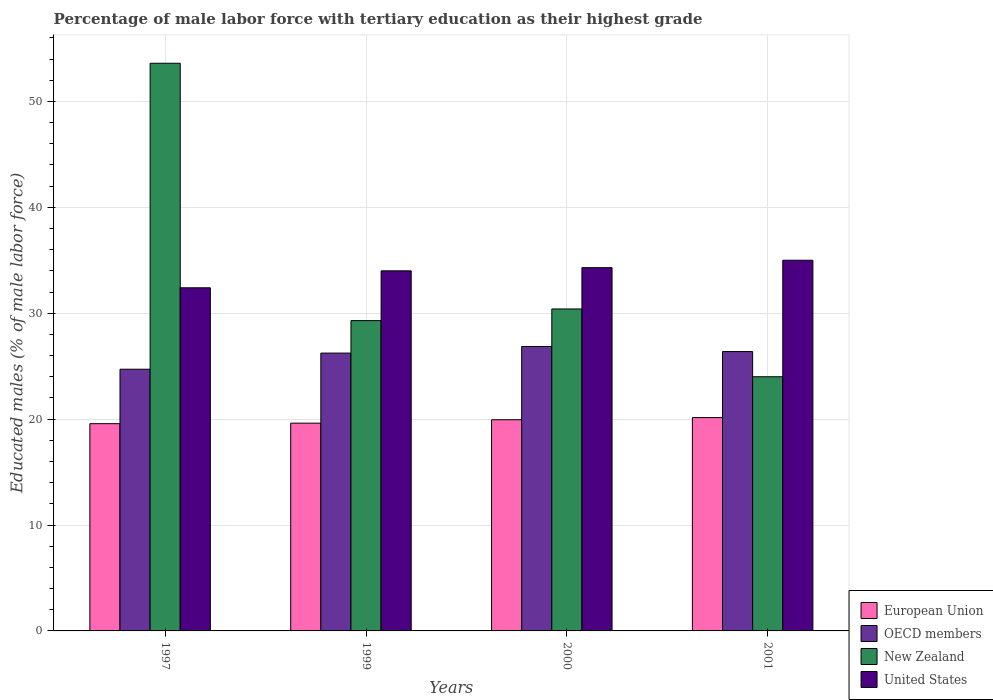How many groups of bars are there?
Offer a very short reply. 4. What is the label of the 1st group of bars from the left?
Your answer should be very brief. 1997. In how many cases, is the number of bars for a given year not equal to the number of legend labels?
Offer a very short reply. 0. What is the percentage of male labor force with tertiary education in European Union in 1999?
Your response must be concise. 19.62. Across all years, what is the maximum percentage of male labor force with tertiary education in OECD members?
Provide a succinct answer. 26.85. Across all years, what is the minimum percentage of male labor force with tertiary education in OECD members?
Give a very brief answer. 24.71. In which year was the percentage of male labor force with tertiary education in OECD members maximum?
Make the answer very short. 2000. In which year was the percentage of male labor force with tertiary education in United States minimum?
Give a very brief answer. 1997. What is the total percentage of male labor force with tertiary education in New Zealand in the graph?
Offer a very short reply. 137.3. What is the difference between the percentage of male labor force with tertiary education in European Union in 1999 and that in 2001?
Your response must be concise. -0.52. What is the difference between the percentage of male labor force with tertiary education in European Union in 2000 and the percentage of male labor force with tertiary education in OECD members in 1997?
Make the answer very short. -4.77. What is the average percentage of male labor force with tertiary education in New Zealand per year?
Offer a very short reply. 34.32. In the year 2000, what is the difference between the percentage of male labor force with tertiary education in New Zealand and percentage of male labor force with tertiary education in OECD members?
Give a very brief answer. 3.55. In how many years, is the percentage of male labor force with tertiary education in United States greater than 40 %?
Give a very brief answer. 0. What is the ratio of the percentage of male labor force with tertiary education in United States in 1997 to that in 1999?
Your answer should be compact. 0.95. Is the percentage of male labor force with tertiary education in OECD members in 1997 less than that in 1999?
Provide a succinct answer. Yes. What is the difference between the highest and the second highest percentage of male labor force with tertiary education in European Union?
Keep it short and to the point. 0.2. What is the difference between the highest and the lowest percentage of male labor force with tertiary education in New Zealand?
Your answer should be very brief. 29.6. In how many years, is the percentage of male labor force with tertiary education in New Zealand greater than the average percentage of male labor force with tertiary education in New Zealand taken over all years?
Provide a short and direct response. 1. Is it the case that in every year, the sum of the percentage of male labor force with tertiary education in European Union and percentage of male labor force with tertiary education in United States is greater than the sum of percentage of male labor force with tertiary education in New Zealand and percentage of male labor force with tertiary education in OECD members?
Offer a very short reply. Yes. How many years are there in the graph?
Ensure brevity in your answer.  4. What is the difference between two consecutive major ticks on the Y-axis?
Your response must be concise. 10. Does the graph contain any zero values?
Ensure brevity in your answer.  No. Does the graph contain grids?
Make the answer very short. Yes. Where does the legend appear in the graph?
Provide a short and direct response. Bottom right. How are the legend labels stacked?
Your response must be concise. Vertical. What is the title of the graph?
Your answer should be compact. Percentage of male labor force with tertiary education as their highest grade. Does "Belarus" appear as one of the legend labels in the graph?
Ensure brevity in your answer.  No. What is the label or title of the Y-axis?
Offer a terse response. Educated males (% of male labor force). What is the Educated males (% of male labor force) of European Union in 1997?
Give a very brief answer. 19.57. What is the Educated males (% of male labor force) in OECD members in 1997?
Provide a short and direct response. 24.71. What is the Educated males (% of male labor force) of New Zealand in 1997?
Make the answer very short. 53.6. What is the Educated males (% of male labor force) of United States in 1997?
Your answer should be compact. 32.4. What is the Educated males (% of male labor force) in European Union in 1999?
Ensure brevity in your answer.  19.62. What is the Educated males (% of male labor force) of OECD members in 1999?
Keep it short and to the point. 26.23. What is the Educated males (% of male labor force) in New Zealand in 1999?
Your response must be concise. 29.3. What is the Educated males (% of male labor force) in European Union in 2000?
Keep it short and to the point. 19.94. What is the Educated males (% of male labor force) of OECD members in 2000?
Provide a short and direct response. 26.85. What is the Educated males (% of male labor force) of New Zealand in 2000?
Ensure brevity in your answer.  30.4. What is the Educated males (% of male labor force) of United States in 2000?
Offer a terse response. 34.3. What is the Educated males (% of male labor force) in European Union in 2001?
Your response must be concise. 20.14. What is the Educated males (% of male labor force) of OECD members in 2001?
Provide a short and direct response. 26.38. What is the Educated males (% of male labor force) of New Zealand in 2001?
Give a very brief answer. 24. Across all years, what is the maximum Educated males (% of male labor force) in European Union?
Your response must be concise. 20.14. Across all years, what is the maximum Educated males (% of male labor force) in OECD members?
Your answer should be very brief. 26.85. Across all years, what is the maximum Educated males (% of male labor force) of New Zealand?
Ensure brevity in your answer.  53.6. Across all years, what is the minimum Educated males (% of male labor force) in European Union?
Provide a short and direct response. 19.57. Across all years, what is the minimum Educated males (% of male labor force) in OECD members?
Provide a succinct answer. 24.71. Across all years, what is the minimum Educated males (% of male labor force) in United States?
Provide a succinct answer. 32.4. What is the total Educated males (% of male labor force) of European Union in the graph?
Your answer should be very brief. 79.27. What is the total Educated males (% of male labor force) in OECD members in the graph?
Keep it short and to the point. 104.18. What is the total Educated males (% of male labor force) in New Zealand in the graph?
Provide a short and direct response. 137.3. What is the total Educated males (% of male labor force) of United States in the graph?
Keep it short and to the point. 135.7. What is the difference between the Educated males (% of male labor force) in European Union in 1997 and that in 1999?
Make the answer very short. -0.05. What is the difference between the Educated males (% of male labor force) in OECD members in 1997 and that in 1999?
Ensure brevity in your answer.  -1.52. What is the difference between the Educated males (% of male labor force) in New Zealand in 1997 and that in 1999?
Your answer should be compact. 24.3. What is the difference between the Educated males (% of male labor force) of United States in 1997 and that in 1999?
Keep it short and to the point. -1.6. What is the difference between the Educated males (% of male labor force) in European Union in 1997 and that in 2000?
Offer a terse response. -0.37. What is the difference between the Educated males (% of male labor force) in OECD members in 1997 and that in 2000?
Make the answer very short. -2.14. What is the difference between the Educated males (% of male labor force) of New Zealand in 1997 and that in 2000?
Keep it short and to the point. 23.2. What is the difference between the Educated males (% of male labor force) in European Union in 1997 and that in 2001?
Your answer should be compact. -0.58. What is the difference between the Educated males (% of male labor force) in OECD members in 1997 and that in 2001?
Ensure brevity in your answer.  -1.67. What is the difference between the Educated males (% of male labor force) of New Zealand in 1997 and that in 2001?
Ensure brevity in your answer.  29.6. What is the difference between the Educated males (% of male labor force) of European Union in 1999 and that in 2000?
Your answer should be compact. -0.32. What is the difference between the Educated males (% of male labor force) of OECD members in 1999 and that in 2000?
Provide a succinct answer. -0.62. What is the difference between the Educated males (% of male labor force) of New Zealand in 1999 and that in 2000?
Make the answer very short. -1.1. What is the difference between the Educated males (% of male labor force) of United States in 1999 and that in 2000?
Your answer should be very brief. -0.3. What is the difference between the Educated males (% of male labor force) of European Union in 1999 and that in 2001?
Make the answer very short. -0.53. What is the difference between the Educated males (% of male labor force) in OECD members in 1999 and that in 2001?
Provide a short and direct response. -0.14. What is the difference between the Educated males (% of male labor force) in United States in 1999 and that in 2001?
Offer a very short reply. -1. What is the difference between the Educated males (% of male labor force) in European Union in 2000 and that in 2001?
Your response must be concise. -0.2. What is the difference between the Educated males (% of male labor force) of OECD members in 2000 and that in 2001?
Offer a terse response. 0.48. What is the difference between the Educated males (% of male labor force) in New Zealand in 2000 and that in 2001?
Offer a terse response. 6.4. What is the difference between the Educated males (% of male labor force) of United States in 2000 and that in 2001?
Give a very brief answer. -0.7. What is the difference between the Educated males (% of male labor force) in European Union in 1997 and the Educated males (% of male labor force) in OECD members in 1999?
Your response must be concise. -6.67. What is the difference between the Educated males (% of male labor force) in European Union in 1997 and the Educated males (% of male labor force) in New Zealand in 1999?
Make the answer very short. -9.73. What is the difference between the Educated males (% of male labor force) in European Union in 1997 and the Educated males (% of male labor force) in United States in 1999?
Provide a short and direct response. -14.43. What is the difference between the Educated males (% of male labor force) of OECD members in 1997 and the Educated males (% of male labor force) of New Zealand in 1999?
Offer a terse response. -4.59. What is the difference between the Educated males (% of male labor force) in OECD members in 1997 and the Educated males (% of male labor force) in United States in 1999?
Your response must be concise. -9.29. What is the difference between the Educated males (% of male labor force) of New Zealand in 1997 and the Educated males (% of male labor force) of United States in 1999?
Make the answer very short. 19.6. What is the difference between the Educated males (% of male labor force) in European Union in 1997 and the Educated males (% of male labor force) in OECD members in 2000?
Your response must be concise. -7.29. What is the difference between the Educated males (% of male labor force) in European Union in 1997 and the Educated males (% of male labor force) in New Zealand in 2000?
Provide a succinct answer. -10.83. What is the difference between the Educated males (% of male labor force) of European Union in 1997 and the Educated males (% of male labor force) of United States in 2000?
Your answer should be compact. -14.73. What is the difference between the Educated males (% of male labor force) in OECD members in 1997 and the Educated males (% of male labor force) in New Zealand in 2000?
Your response must be concise. -5.69. What is the difference between the Educated males (% of male labor force) in OECD members in 1997 and the Educated males (% of male labor force) in United States in 2000?
Make the answer very short. -9.59. What is the difference between the Educated males (% of male labor force) of New Zealand in 1997 and the Educated males (% of male labor force) of United States in 2000?
Provide a short and direct response. 19.3. What is the difference between the Educated males (% of male labor force) in European Union in 1997 and the Educated males (% of male labor force) in OECD members in 2001?
Keep it short and to the point. -6.81. What is the difference between the Educated males (% of male labor force) in European Union in 1997 and the Educated males (% of male labor force) in New Zealand in 2001?
Offer a very short reply. -4.43. What is the difference between the Educated males (% of male labor force) of European Union in 1997 and the Educated males (% of male labor force) of United States in 2001?
Your answer should be very brief. -15.43. What is the difference between the Educated males (% of male labor force) of OECD members in 1997 and the Educated males (% of male labor force) of New Zealand in 2001?
Your answer should be very brief. 0.71. What is the difference between the Educated males (% of male labor force) in OECD members in 1997 and the Educated males (% of male labor force) in United States in 2001?
Give a very brief answer. -10.29. What is the difference between the Educated males (% of male labor force) in European Union in 1999 and the Educated males (% of male labor force) in OECD members in 2000?
Your response must be concise. -7.24. What is the difference between the Educated males (% of male labor force) in European Union in 1999 and the Educated males (% of male labor force) in New Zealand in 2000?
Your response must be concise. -10.78. What is the difference between the Educated males (% of male labor force) in European Union in 1999 and the Educated males (% of male labor force) in United States in 2000?
Offer a very short reply. -14.68. What is the difference between the Educated males (% of male labor force) of OECD members in 1999 and the Educated males (% of male labor force) of New Zealand in 2000?
Give a very brief answer. -4.17. What is the difference between the Educated males (% of male labor force) in OECD members in 1999 and the Educated males (% of male labor force) in United States in 2000?
Make the answer very short. -8.07. What is the difference between the Educated males (% of male labor force) in European Union in 1999 and the Educated males (% of male labor force) in OECD members in 2001?
Provide a succinct answer. -6.76. What is the difference between the Educated males (% of male labor force) of European Union in 1999 and the Educated males (% of male labor force) of New Zealand in 2001?
Provide a succinct answer. -4.38. What is the difference between the Educated males (% of male labor force) in European Union in 1999 and the Educated males (% of male labor force) in United States in 2001?
Keep it short and to the point. -15.38. What is the difference between the Educated males (% of male labor force) in OECD members in 1999 and the Educated males (% of male labor force) in New Zealand in 2001?
Keep it short and to the point. 2.23. What is the difference between the Educated males (% of male labor force) in OECD members in 1999 and the Educated males (% of male labor force) in United States in 2001?
Provide a succinct answer. -8.77. What is the difference between the Educated males (% of male labor force) of New Zealand in 1999 and the Educated males (% of male labor force) of United States in 2001?
Offer a terse response. -5.7. What is the difference between the Educated males (% of male labor force) of European Union in 2000 and the Educated males (% of male labor force) of OECD members in 2001?
Your answer should be very brief. -6.44. What is the difference between the Educated males (% of male labor force) of European Union in 2000 and the Educated males (% of male labor force) of New Zealand in 2001?
Provide a short and direct response. -4.06. What is the difference between the Educated males (% of male labor force) of European Union in 2000 and the Educated males (% of male labor force) of United States in 2001?
Provide a succinct answer. -15.06. What is the difference between the Educated males (% of male labor force) in OECD members in 2000 and the Educated males (% of male labor force) in New Zealand in 2001?
Ensure brevity in your answer.  2.85. What is the difference between the Educated males (% of male labor force) of OECD members in 2000 and the Educated males (% of male labor force) of United States in 2001?
Give a very brief answer. -8.15. What is the difference between the Educated males (% of male labor force) in New Zealand in 2000 and the Educated males (% of male labor force) in United States in 2001?
Your response must be concise. -4.6. What is the average Educated males (% of male labor force) of European Union per year?
Make the answer very short. 19.82. What is the average Educated males (% of male labor force) in OECD members per year?
Offer a terse response. 26.04. What is the average Educated males (% of male labor force) in New Zealand per year?
Your answer should be very brief. 34.33. What is the average Educated males (% of male labor force) of United States per year?
Your response must be concise. 33.92. In the year 1997, what is the difference between the Educated males (% of male labor force) in European Union and Educated males (% of male labor force) in OECD members?
Provide a succinct answer. -5.14. In the year 1997, what is the difference between the Educated males (% of male labor force) in European Union and Educated males (% of male labor force) in New Zealand?
Your answer should be compact. -34.03. In the year 1997, what is the difference between the Educated males (% of male labor force) in European Union and Educated males (% of male labor force) in United States?
Offer a very short reply. -12.83. In the year 1997, what is the difference between the Educated males (% of male labor force) of OECD members and Educated males (% of male labor force) of New Zealand?
Keep it short and to the point. -28.89. In the year 1997, what is the difference between the Educated males (% of male labor force) of OECD members and Educated males (% of male labor force) of United States?
Your response must be concise. -7.69. In the year 1997, what is the difference between the Educated males (% of male labor force) in New Zealand and Educated males (% of male labor force) in United States?
Offer a very short reply. 21.2. In the year 1999, what is the difference between the Educated males (% of male labor force) of European Union and Educated males (% of male labor force) of OECD members?
Provide a succinct answer. -6.61. In the year 1999, what is the difference between the Educated males (% of male labor force) of European Union and Educated males (% of male labor force) of New Zealand?
Offer a very short reply. -9.68. In the year 1999, what is the difference between the Educated males (% of male labor force) of European Union and Educated males (% of male labor force) of United States?
Ensure brevity in your answer.  -14.38. In the year 1999, what is the difference between the Educated males (% of male labor force) in OECD members and Educated males (% of male labor force) in New Zealand?
Provide a short and direct response. -3.07. In the year 1999, what is the difference between the Educated males (% of male labor force) in OECD members and Educated males (% of male labor force) in United States?
Your response must be concise. -7.77. In the year 1999, what is the difference between the Educated males (% of male labor force) in New Zealand and Educated males (% of male labor force) in United States?
Make the answer very short. -4.7. In the year 2000, what is the difference between the Educated males (% of male labor force) in European Union and Educated males (% of male labor force) in OECD members?
Your response must be concise. -6.91. In the year 2000, what is the difference between the Educated males (% of male labor force) in European Union and Educated males (% of male labor force) in New Zealand?
Your answer should be compact. -10.46. In the year 2000, what is the difference between the Educated males (% of male labor force) in European Union and Educated males (% of male labor force) in United States?
Provide a succinct answer. -14.36. In the year 2000, what is the difference between the Educated males (% of male labor force) of OECD members and Educated males (% of male labor force) of New Zealand?
Provide a short and direct response. -3.55. In the year 2000, what is the difference between the Educated males (% of male labor force) of OECD members and Educated males (% of male labor force) of United States?
Offer a terse response. -7.45. In the year 2000, what is the difference between the Educated males (% of male labor force) in New Zealand and Educated males (% of male labor force) in United States?
Make the answer very short. -3.9. In the year 2001, what is the difference between the Educated males (% of male labor force) in European Union and Educated males (% of male labor force) in OECD members?
Make the answer very short. -6.23. In the year 2001, what is the difference between the Educated males (% of male labor force) of European Union and Educated males (% of male labor force) of New Zealand?
Offer a very short reply. -3.86. In the year 2001, what is the difference between the Educated males (% of male labor force) in European Union and Educated males (% of male labor force) in United States?
Make the answer very short. -14.86. In the year 2001, what is the difference between the Educated males (% of male labor force) in OECD members and Educated males (% of male labor force) in New Zealand?
Your answer should be very brief. 2.38. In the year 2001, what is the difference between the Educated males (% of male labor force) of OECD members and Educated males (% of male labor force) of United States?
Provide a succinct answer. -8.62. What is the ratio of the Educated males (% of male labor force) in European Union in 1997 to that in 1999?
Offer a terse response. 1. What is the ratio of the Educated males (% of male labor force) in OECD members in 1997 to that in 1999?
Make the answer very short. 0.94. What is the ratio of the Educated males (% of male labor force) of New Zealand in 1997 to that in 1999?
Make the answer very short. 1.83. What is the ratio of the Educated males (% of male labor force) in United States in 1997 to that in 1999?
Your response must be concise. 0.95. What is the ratio of the Educated males (% of male labor force) in European Union in 1997 to that in 2000?
Keep it short and to the point. 0.98. What is the ratio of the Educated males (% of male labor force) of OECD members in 1997 to that in 2000?
Give a very brief answer. 0.92. What is the ratio of the Educated males (% of male labor force) in New Zealand in 1997 to that in 2000?
Provide a short and direct response. 1.76. What is the ratio of the Educated males (% of male labor force) of United States in 1997 to that in 2000?
Provide a short and direct response. 0.94. What is the ratio of the Educated males (% of male labor force) in European Union in 1997 to that in 2001?
Ensure brevity in your answer.  0.97. What is the ratio of the Educated males (% of male labor force) in OECD members in 1997 to that in 2001?
Keep it short and to the point. 0.94. What is the ratio of the Educated males (% of male labor force) in New Zealand in 1997 to that in 2001?
Provide a succinct answer. 2.23. What is the ratio of the Educated males (% of male labor force) of United States in 1997 to that in 2001?
Make the answer very short. 0.93. What is the ratio of the Educated males (% of male labor force) in European Union in 1999 to that in 2000?
Ensure brevity in your answer.  0.98. What is the ratio of the Educated males (% of male labor force) in OECD members in 1999 to that in 2000?
Keep it short and to the point. 0.98. What is the ratio of the Educated males (% of male labor force) in New Zealand in 1999 to that in 2000?
Offer a very short reply. 0.96. What is the ratio of the Educated males (% of male labor force) in European Union in 1999 to that in 2001?
Keep it short and to the point. 0.97. What is the ratio of the Educated males (% of male labor force) of New Zealand in 1999 to that in 2001?
Provide a short and direct response. 1.22. What is the ratio of the Educated males (% of male labor force) in United States in 1999 to that in 2001?
Provide a succinct answer. 0.97. What is the ratio of the Educated males (% of male labor force) in OECD members in 2000 to that in 2001?
Offer a terse response. 1.02. What is the ratio of the Educated males (% of male labor force) in New Zealand in 2000 to that in 2001?
Keep it short and to the point. 1.27. What is the ratio of the Educated males (% of male labor force) in United States in 2000 to that in 2001?
Keep it short and to the point. 0.98. What is the difference between the highest and the second highest Educated males (% of male labor force) in European Union?
Provide a short and direct response. 0.2. What is the difference between the highest and the second highest Educated males (% of male labor force) of OECD members?
Give a very brief answer. 0.48. What is the difference between the highest and the second highest Educated males (% of male labor force) in New Zealand?
Give a very brief answer. 23.2. What is the difference between the highest and the second highest Educated males (% of male labor force) in United States?
Make the answer very short. 0.7. What is the difference between the highest and the lowest Educated males (% of male labor force) of European Union?
Your answer should be very brief. 0.58. What is the difference between the highest and the lowest Educated males (% of male labor force) in OECD members?
Offer a terse response. 2.14. What is the difference between the highest and the lowest Educated males (% of male labor force) of New Zealand?
Provide a short and direct response. 29.6. 